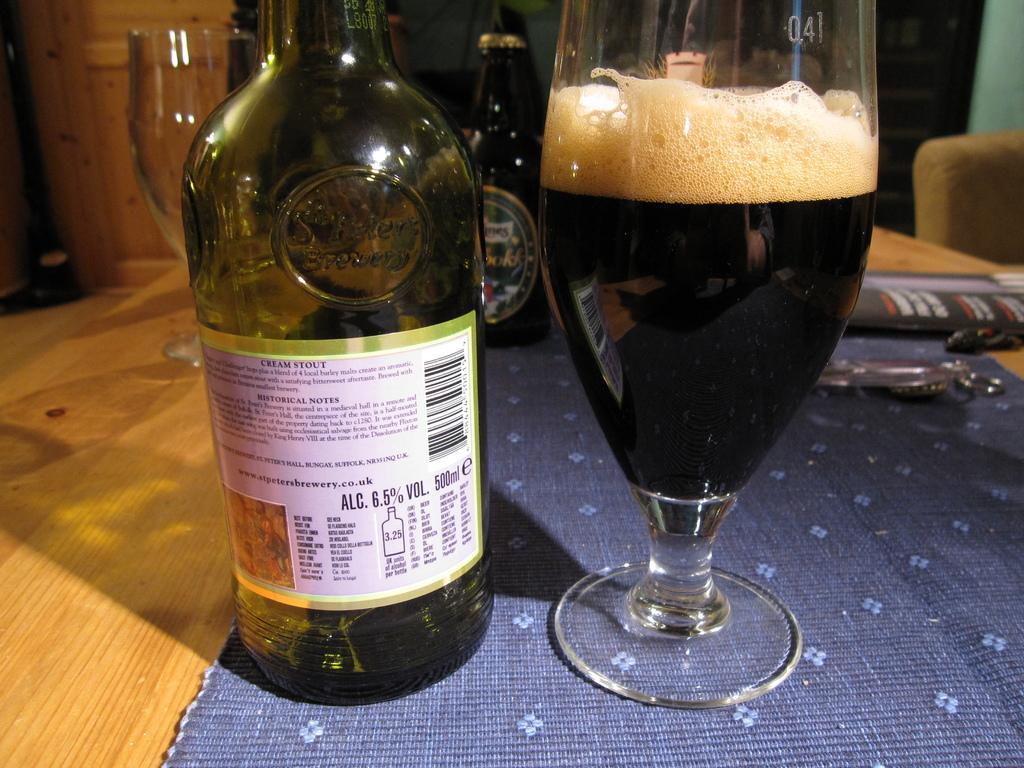Can you describe this image briefly? In the picture we can see a wooden table and a blue color cloth on it, on the cloth we can see a glass of wine and a wine bottle which is green in color and in the background we can also see one more bottle which is black and a wooden wall. 